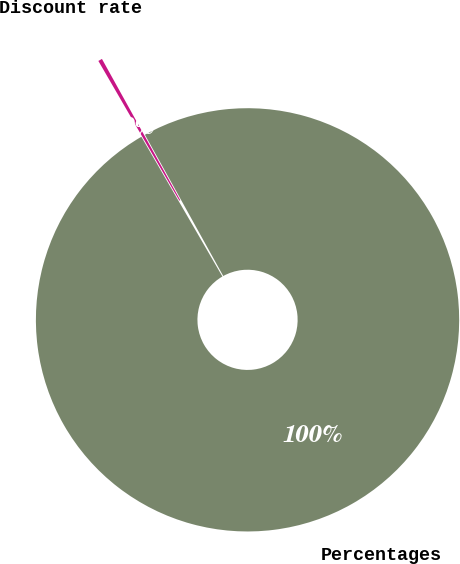Convert chart. <chart><loc_0><loc_0><loc_500><loc_500><pie_chart><fcel>Percentages<fcel>Discount rate<nl><fcel>99.69%<fcel>0.31%<nl></chart> 